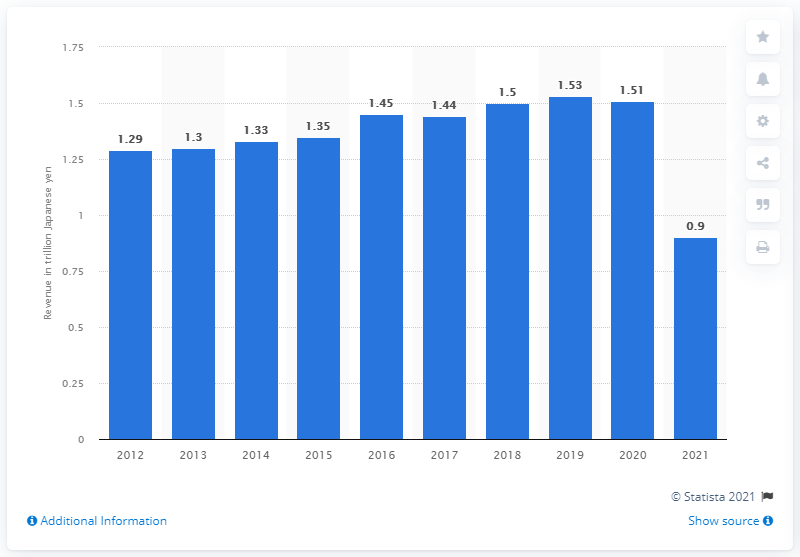Mention a couple of crucial points in this snapshot. JR West generated 0.9 billion Japanese yen in 2021. 